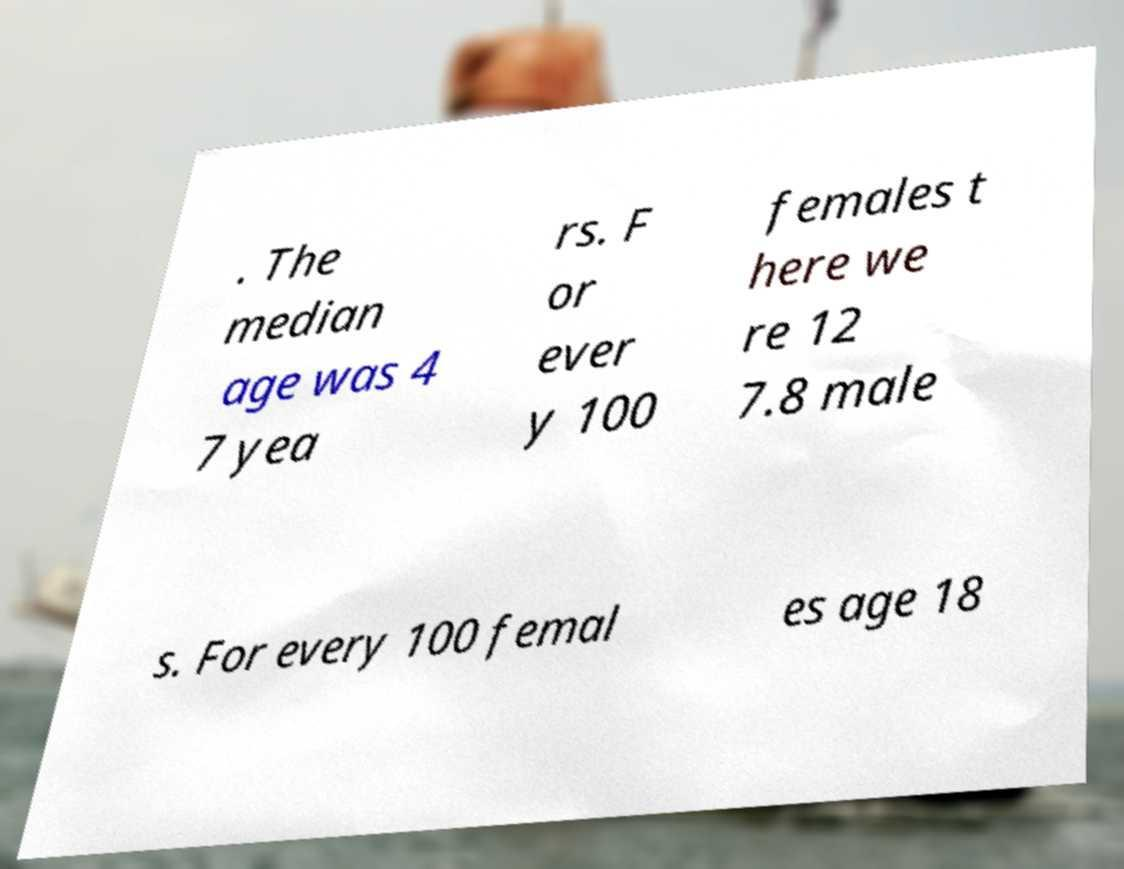What messages or text are displayed in this image? I need them in a readable, typed format. . The median age was 4 7 yea rs. F or ever y 100 females t here we re 12 7.8 male s. For every 100 femal es age 18 